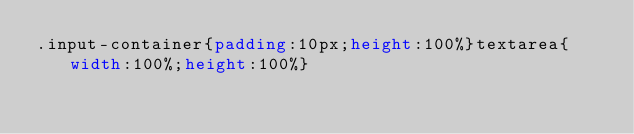Convert code to text. <code><loc_0><loc_0><loc_500><loc_500><_CSS_>.input-container{padding:10px;height:100%}textarea{width:100%;height:100%}
</code> 